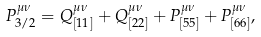Convert formula to latex. <formula><loc_0><loc_0><loc_500><loc_500>P _ { 3 / 2 } ^ { \mu \nu } = Q ^ { \mu \nu } _ { [ 1 1 ] } + Q ^ { \mu \nu } _ { [ 2 2 ] } + P ^ { \mu \nu } _ { [ 5 5 ] } + P ^ { \mu \nu } _ { [ 6 6 ] } ,</formula> 